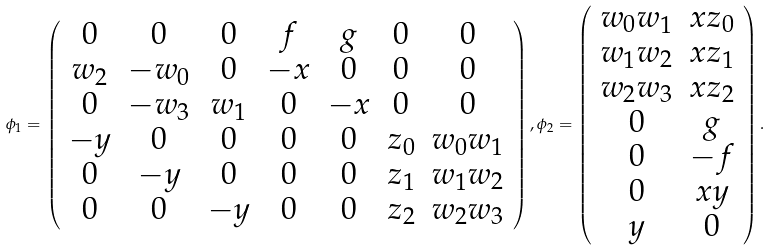Convert formula to latex. <formula><loc_0><loc_0><loc_500><loc_500>\phi _ { 1 } = \left ( \begin{array} { c c c c c c c } 0 & 0 & 0 & f & g & 0 & 0 \\ w _ { 2 } & - w _ { 0 } & 0 & - x & 0 & 0 & 0 \\ 0 & - w _ { 3 } & w _ { 1 } & 0 & - x & 0 & 0 \\ - y & 0 & 0 & 0 & 0 & z _ { 0 } & w _ { 0 } w _ { 1 } \\ 0 & - y & 0 & 0 & 0 & z _ { 1 } & w _ { 1 } w _ { 2 } \\ 0 & 0 & - y & 0 & 0 & z _ { 2 } & w _ { 2 } w _ { 3 } \\ \end{array} \right ) , \phi _ { 2 } = \left ( \begin{array} { c c } w _ { 0 } w _ { 1 } & x z _ { 0 } \\ w _ { 1 } w _ { 2 } & x z _ { 1 } \\ w _ { 2 } w _ { 3 } & x z _ { 2 } \\ 0 & g \\ 0 & - f \\ 0 & x y \\ y & 0 \\ \end{array} \right ) .</formula> 